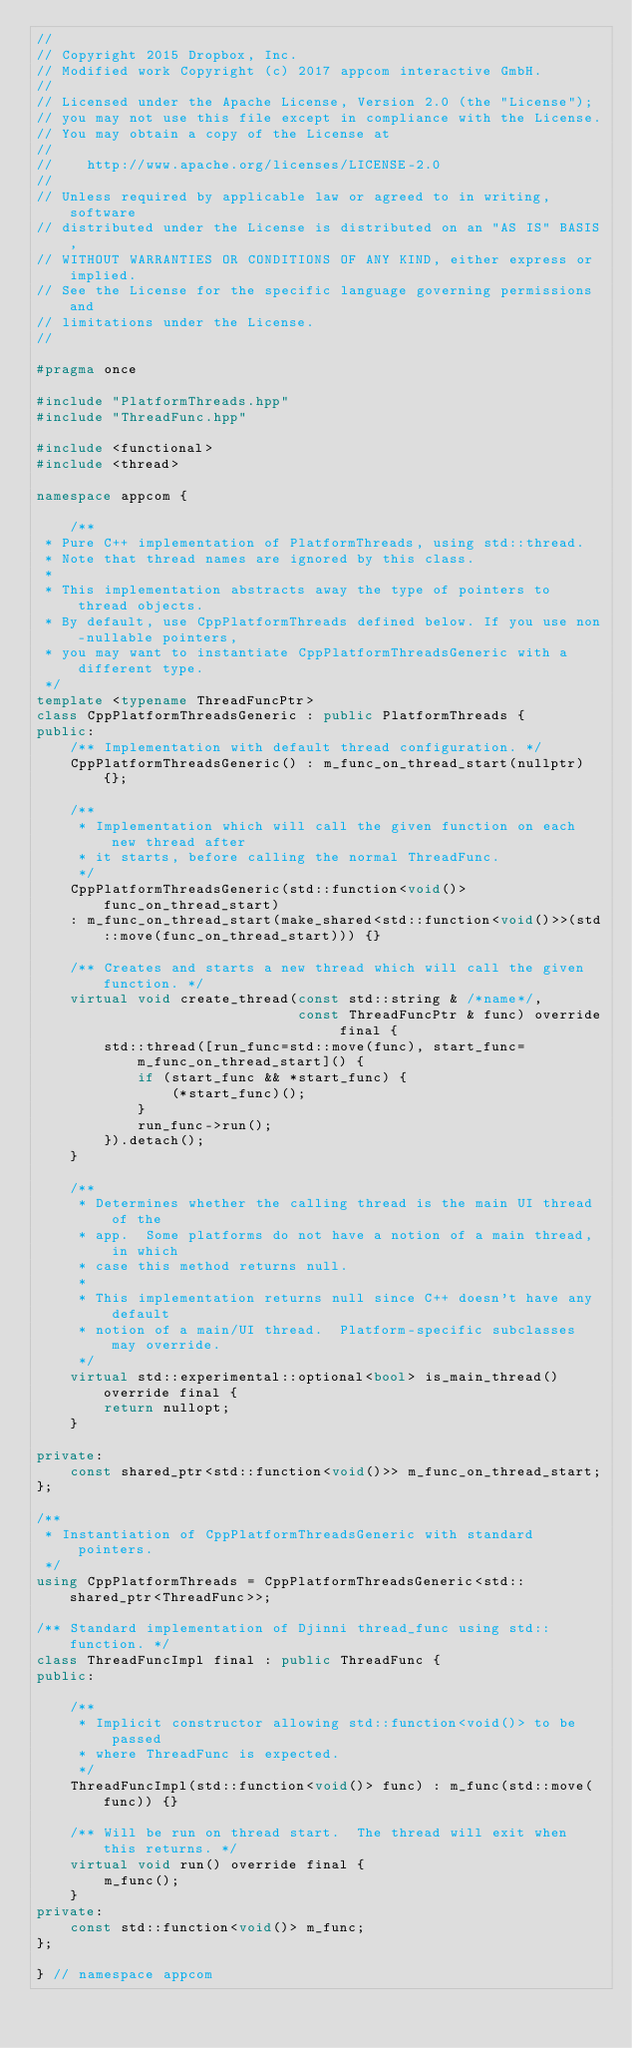Convert code to text. <code><loc_0><loc_0><loc_500><loc_500><_C++_>//
// Copyright 2015 Dropbox, Inc.
// Modified work Copyright (c) 2017 appcom interactive GmbH.
//
// Licensed under the Apache License, Version 2.0 (the "License");
// you may not use this file except in compliance with the License.
// You may obtain a copy of the License at
//
//    http://www.apache.org/licenses/LICENSE-2.0
//
// Unless required by applicable law or agreed to in writing, software
// distributed under the License is distributed on an "AS IS" BASIS,
// WITHOUT WARRANTIES OR CONDITIONS OF ANY KIND, either express or implied.
// See the License for the specific language governing permissions and
// limitations under the License.
//

#pragma once

#include "PlatformThreads.hpp"
#include "ThreadFunc.hpp"

#include <functional>
#include <thread>

namespace appcom {

    /**
 * Pure C++ implementation of PlatformThreads, using std::thread.
 * Note that thread names are ignored by this class.
 *
 * This implementation abstracts away the type of pointers to thread objects.
 * By default, use CppPlatformThreads defined below. If you use non-nullable pointers,
 * you may want to instantiate CppPlatformThreadsGeneric with a different type.
 */
template <typename ThreadFuncPtr>
class CppPlatformThreadsGeneric : public PlatformThreads {
public:
    /** Implementation with default thread configuration. */
    CppPlatformThreadsGeneric() : m_func_on_thread_start(nullptr) {};

    /**
     * Implementation which will call the given function on each new thread after
     * it starts, before calling the normal ThreadFunc.
     */
    CppPlatformThreadsGeneric(std::function<void()> func_on_thread_start)
    : m_func_on_thread_start(make_shared<std::function<void()>>(std::move(func_on_thread_start))) {}

    /** Creates and starts a new thread which will call the given function. */
    virtual void create_thread(const std::string & /*name*/,
                               const ThreadFuncPtr & func) override final {
        std::thread([run_func=std::move(func), start_func=m_func_on_thread_start]() {
            if (start_func && *start_func) {
                (*start_func)();
            }
            run_func->run();
        }).detach();
    }

    /**
     * Determines whether the calling thread is the main UI thread of the
     * app.  Some platforms do not have a notion of a main thread, in which
     * case this method returns null.
     *
     * This implementation returns null since C++ doesn't have any default
     * notion of a main/UI thread.  Platform-specific subclasses may override.
     */
    virtual std::experimental::optional<bool> is_main_thread() override final {
        return nullopt;
    }

private:
    const shared_ptr<std::function<void()>> m_func_on_thread_start;
};

/**
 * Instantiation of CppPlatformThreadsGeneric with standard pointers.
 */
using CppPlatformThreads = CppPlatformThreadsGeneric<std::shared_ptr<ThreadFunc>>;

/** Standard implementation of Djinni thread_func using std::function. */
class ThreadFuncImpl final : public ThreadFunc {
public:

    /**
     * Implicit constructor allowing std::function<void()> to be passed
     * where ThreadFunc is expected.
     */
    ThreadFuncImpl(std::function<void()> func) : m_func(std::move(func)) {}

    /** Will be run on thread start.  The thread will exit when this returns. */
    virtual void run() override final {
        m_func();
    }
private:
    const std::function<void()> m_func;
};

} // namespace appcom
</code> 